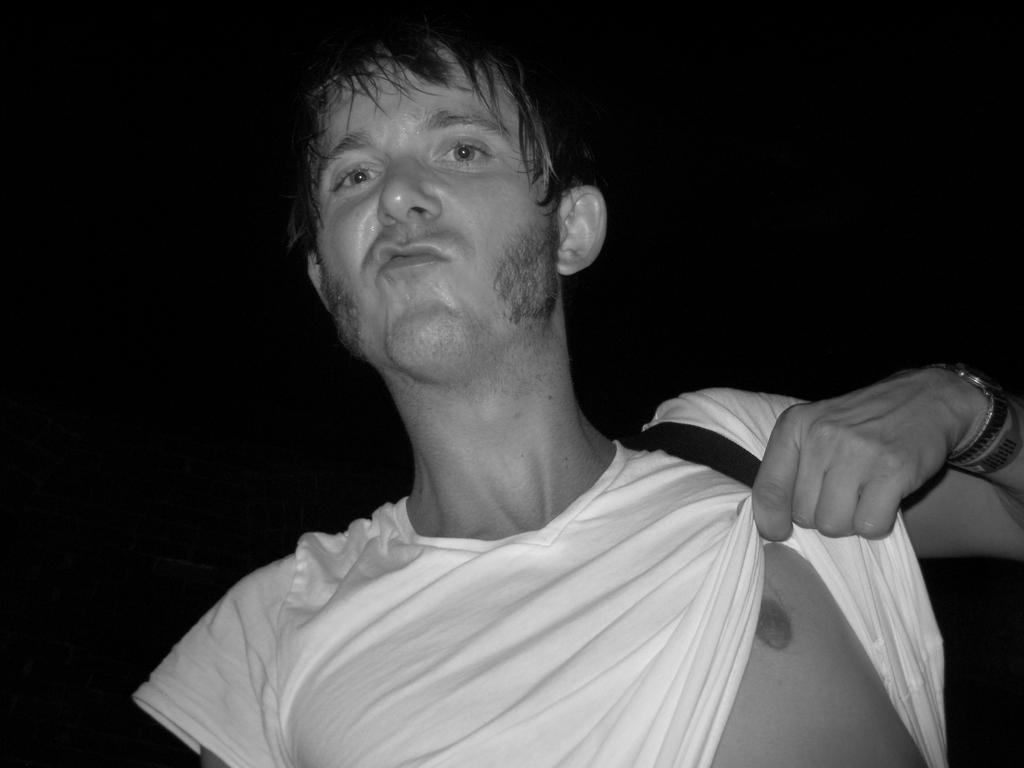Who or what is the main subject in the image? There is a person in the image. What is the person wearing? The person is wearing a dress. What color is the background of the image? The background of the image is black. What type of nose can be seen on the boat in the image? There is no boat present in the image, and therefore no nose can be seen on a boat. 